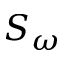Convert formula to latex. <formula><loc_0><loc_0><loc_500><loc_500>S _ { \omega }</formula> 